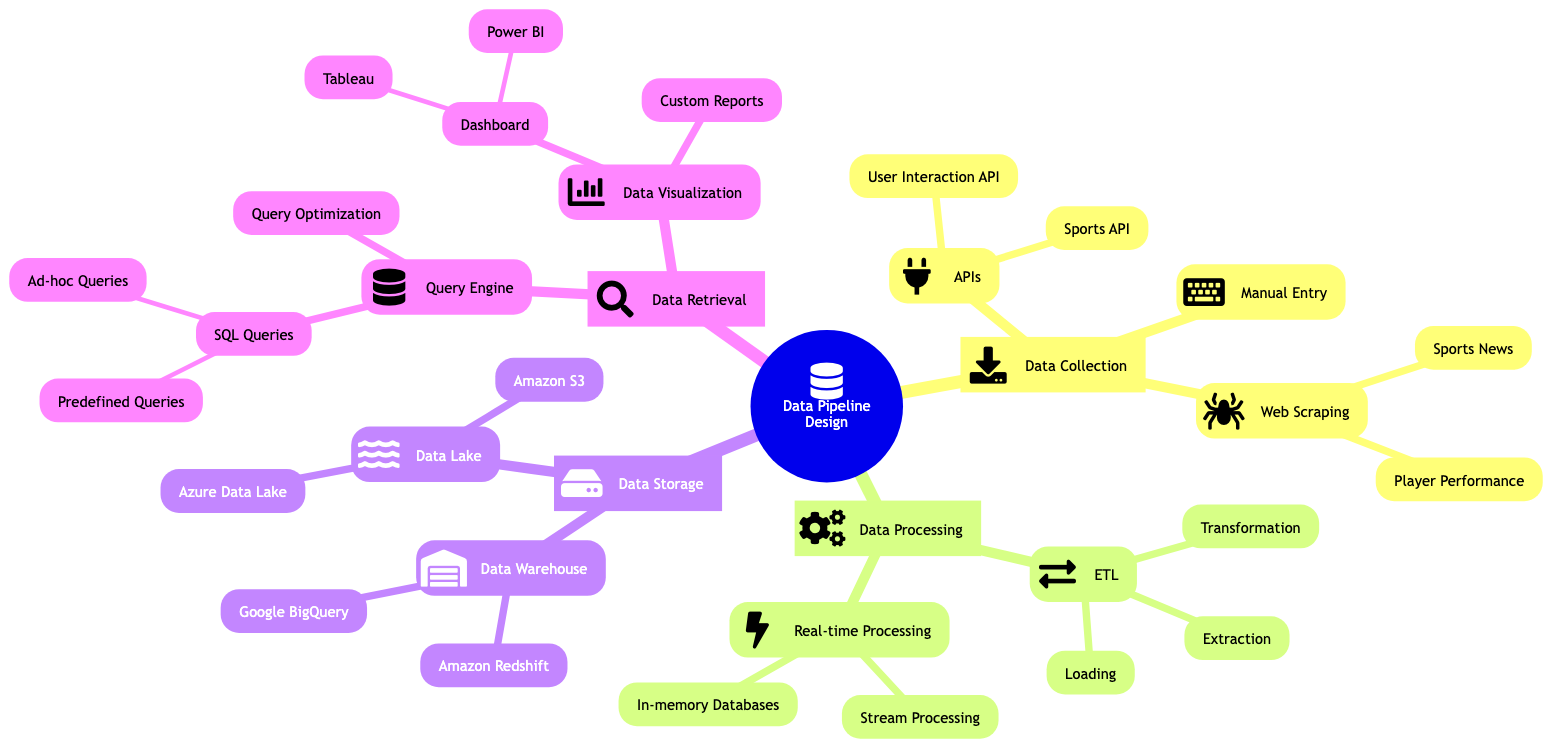What are the three methods of data collection listed in the diagram? The diagram lists three methods under "Data Collection": APIs, Web Scraping, and Manual Entry. Each of these methods is a separate node connected to the main collection point.
Answer: APIs, Web Scraping, Manual Entry How many storage solutions are listed under Data Storage? The "Data Storage" section has two main categories: Data Warehouse and Data Lake. Each of these categories contains respective solutions, but the count of the main categories is what's being asked here, which is 2.
Answer: 2 What technology is used for real-time processing of data streams? In the "Real-time Processing" section, the technology specified for handling incoming data streams is Apache Kafka. This information is directly derived from the respective node in the diagram.
Answer: Apache Kafka How many types of storage solutions are mentioned under Data Warehouse? Under the "Data Warehouse" node, there are two types of storage solutions listed: Amazon Redshift and Google BigQuery. This means we need to count these specific entries.
Answer: 2 What is the primary function of the User Interaction API? According to the diagram, the User Interaction API is used to collect data from user interactions within the platform. This information can be found under the APIs category of Data Collection.
Answer: Collect data from user interactions What are the tools mentioned for data visualization in the diagram? The diagram specifies tools under the "Data Visualization" section: Tableau and Power BI. Thus, we can directly list these as the main visualization tools presented in the diagram.
Answer: Tableau, Power BI Which node details the extraction, transformation, and loading processes? The node that details these processes is "ETL (Extract, Transform, Load)" located under the "Data Processing" section. Each of these processes is a sub-node of the ETL category.
Answer: ETL (Extract, Transform, Load) What type of database is used for in-memory processing? Under the "Real-time Processing" section, the diagram states that Redis is used for in-memory databases, highlighting its role in processing data in real-time.
Answer: Redis What type of queries can be categorized as routine queries for common analytics? The diagram outlines "Predefined Queries" as the routine queries for common analytics, which is found under the SQL Queries category of the query engine for data retrieval.
Answer: Predefined Queries 